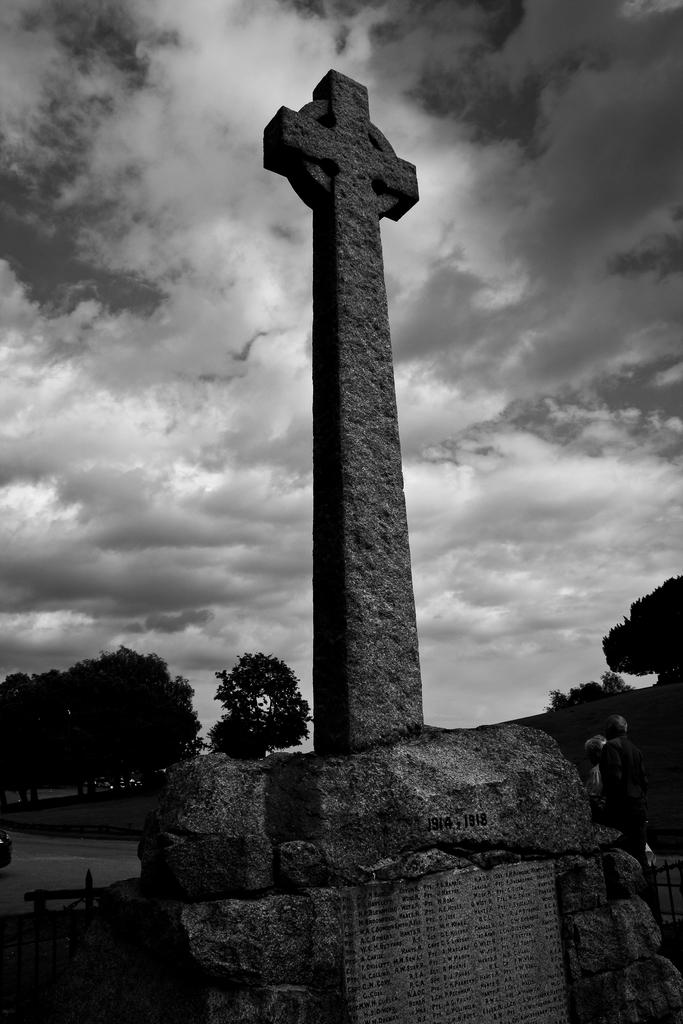What symbol is located in the center of the image? There is a plus sign in the center of the image. What can be seen in the background of the image? There are people and trees in the background. What type of stamp can be seen on the plus sign in the image? There is no stamp present on the plus sign in the image. How many people are laughing in the background of the image? The provided facts do not mention laughter or the number of people, so we cannot determine this information from the image. 